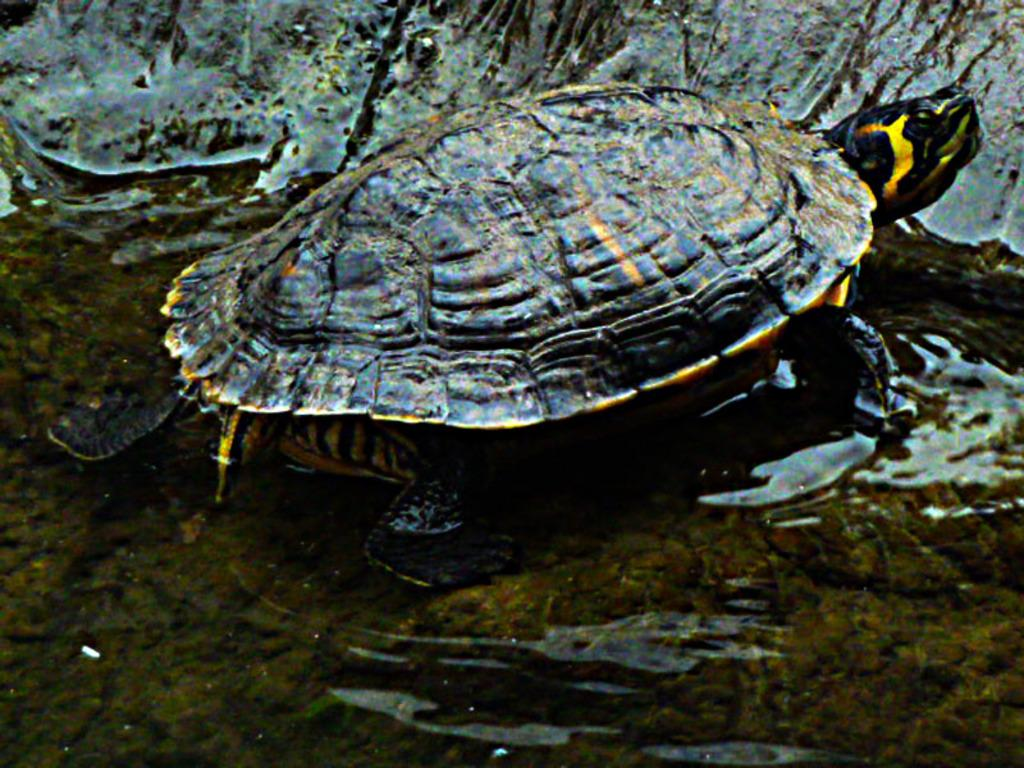What type of animal is in the image? There is a tortoise in the image. Where is the tortoise located? The tortoise is in the water. How many parents can be seen in the image? There are no parents present in the image, as it features a tortoise in the water. 